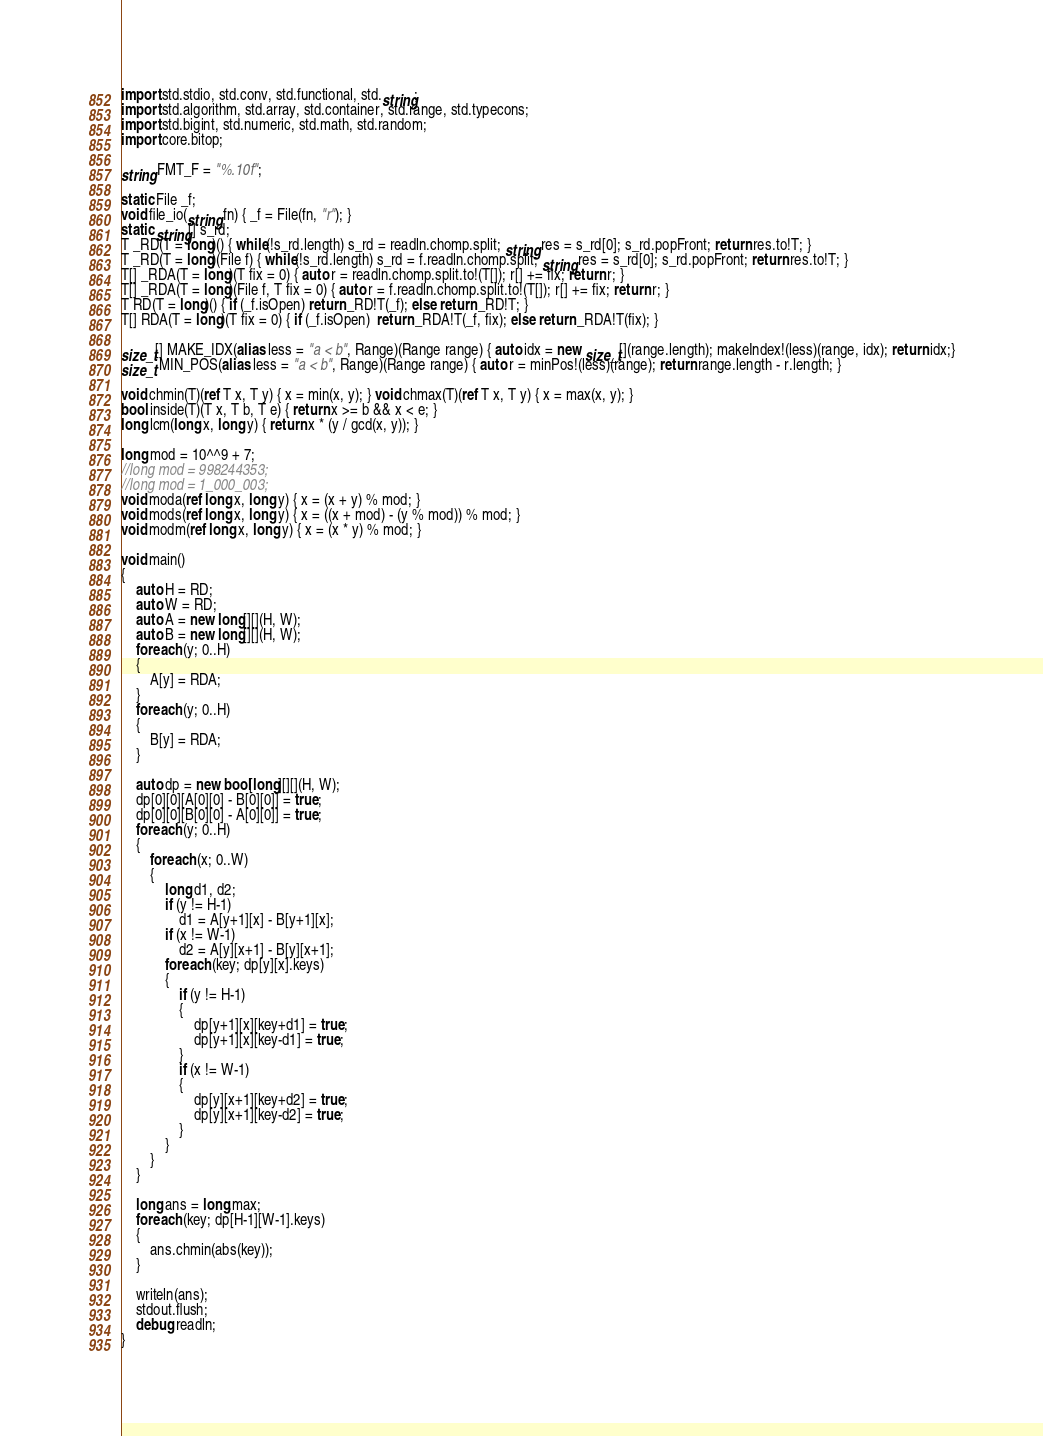<code> <loc_0><loc_0><loc_500><loc_500><_D_>import std.stdio, std.conv, std.functional, std.string;
import std.algorithm, std.array, std.container, std.range, std.typecons;
import std.bigint, std.numeric, std.math, std.random;
import core.bitop;

string FMT_F = "%.10f";

static File _f;
void file_io(string fn) { _f = File(fn, "r"); }
static string[] s_rd;
T _RD(T = long)() { while(!s_rd.length) s_rd = readln.chomp.split; string res = s_rd[0]; s_rd.popFront; return res.to!T; }
T _RD(T = long)(File f) { while(!s_rd.length) s_rd = f.readln.chomp.split; string res = s_rd[0]; s_rd.popFront; return res.to!T; }
T[] _RDA(T = long)(T fix = 0) { auto r = readln.chomp.split.to!(T[]); r[] += fix; return r; }
T[] _RDA(T = long)(File f, T fix = 0) { auto r = f.readln.chomp.split.to!(T[]); r[] += fix; return r; }
T RD(T = long)() { if (_f.isOpen) return _RD!T(_f); else return _RD!T; }
T[] RDA(T = long)(T fix = 0) { if (_f.isOpen)  return _RDA!T(_f, fix); else return _RDA!T(fix); }

size_t[] MAKE_IDX(alias less = "a < b", Range)(Range range) { auto idx = new size_t[](range.length); makeIndex!(less)(range, idx); return idx;}
size_t MIN_POS(alias less = "a < b", Range)(Range range) { auto r = minPos!(less)(range); return range.length - r.length; }

void chmin(T)(ref T x, T y) { x = min(x, y); } void chmax(T)(ref T x, T y) { x = max(x, y); }
bool inside(T)(T x, T b, T e) { return x >= b && x < e; }
long lcm(long x, long y) { return x * (y / gcd(x, y)); }

long mod = 10^^9 + 7;
//long mod = 998244353;
//long mod = 1_000_003;
void moda(ref long x, long y) { x = (x + y) % mod; }
void mods(ref long x, long y) { x = ((x + mod) - (y % mod)) % mod; }
void modm(ref long x, long y) { x = (x * y) % mod; }

void main()
{
	auto H = RD;
	auto W = RD;
	auto A = new long[][](H, W);
	auto B = new long[][](H, W);
	foreach (y; 0..H)
	{
		A[y] = RDA;
	}
	foreach (y; 0..H)
	{
		B[y] = RDA;
	}

	auto dp = new bool[long][][](H, W);
	dp[0][0][A[0][0] - B[0][0]] = true;
	dp[0][0][B[0][0] - A[0][0]] = true;
	foreach (y; 0..H)
	{
		foreach (x; 0..W)
		{
			long d1, d2;
			if (y != H-1)
				d1 = A[y+1][x] - B[y+1][x];
			if (x != W-1)
				d2 = A[y][x+1] - B[y][x+1];
			foreach (key; dp[y][x].keys)
			{
				if (y != H-1)
				{
					dp[y+1][x][key+d1] = true;
					dp[y+1][x][key-d1] = true;
				}
				if (x != W-1)
				{
					dp[y][x+1][key+d2] = true;
					dp[y][x+1][key-d2] = true;
				}
			}
		}
	}

	long ans = long.max;
	foreach (key; dp[H-1][W-1].keys)
	{
		ans.chmin(abs(key));
	}

	writeln(ans);
	stdout.flush;
	debug readln;
}</code> 